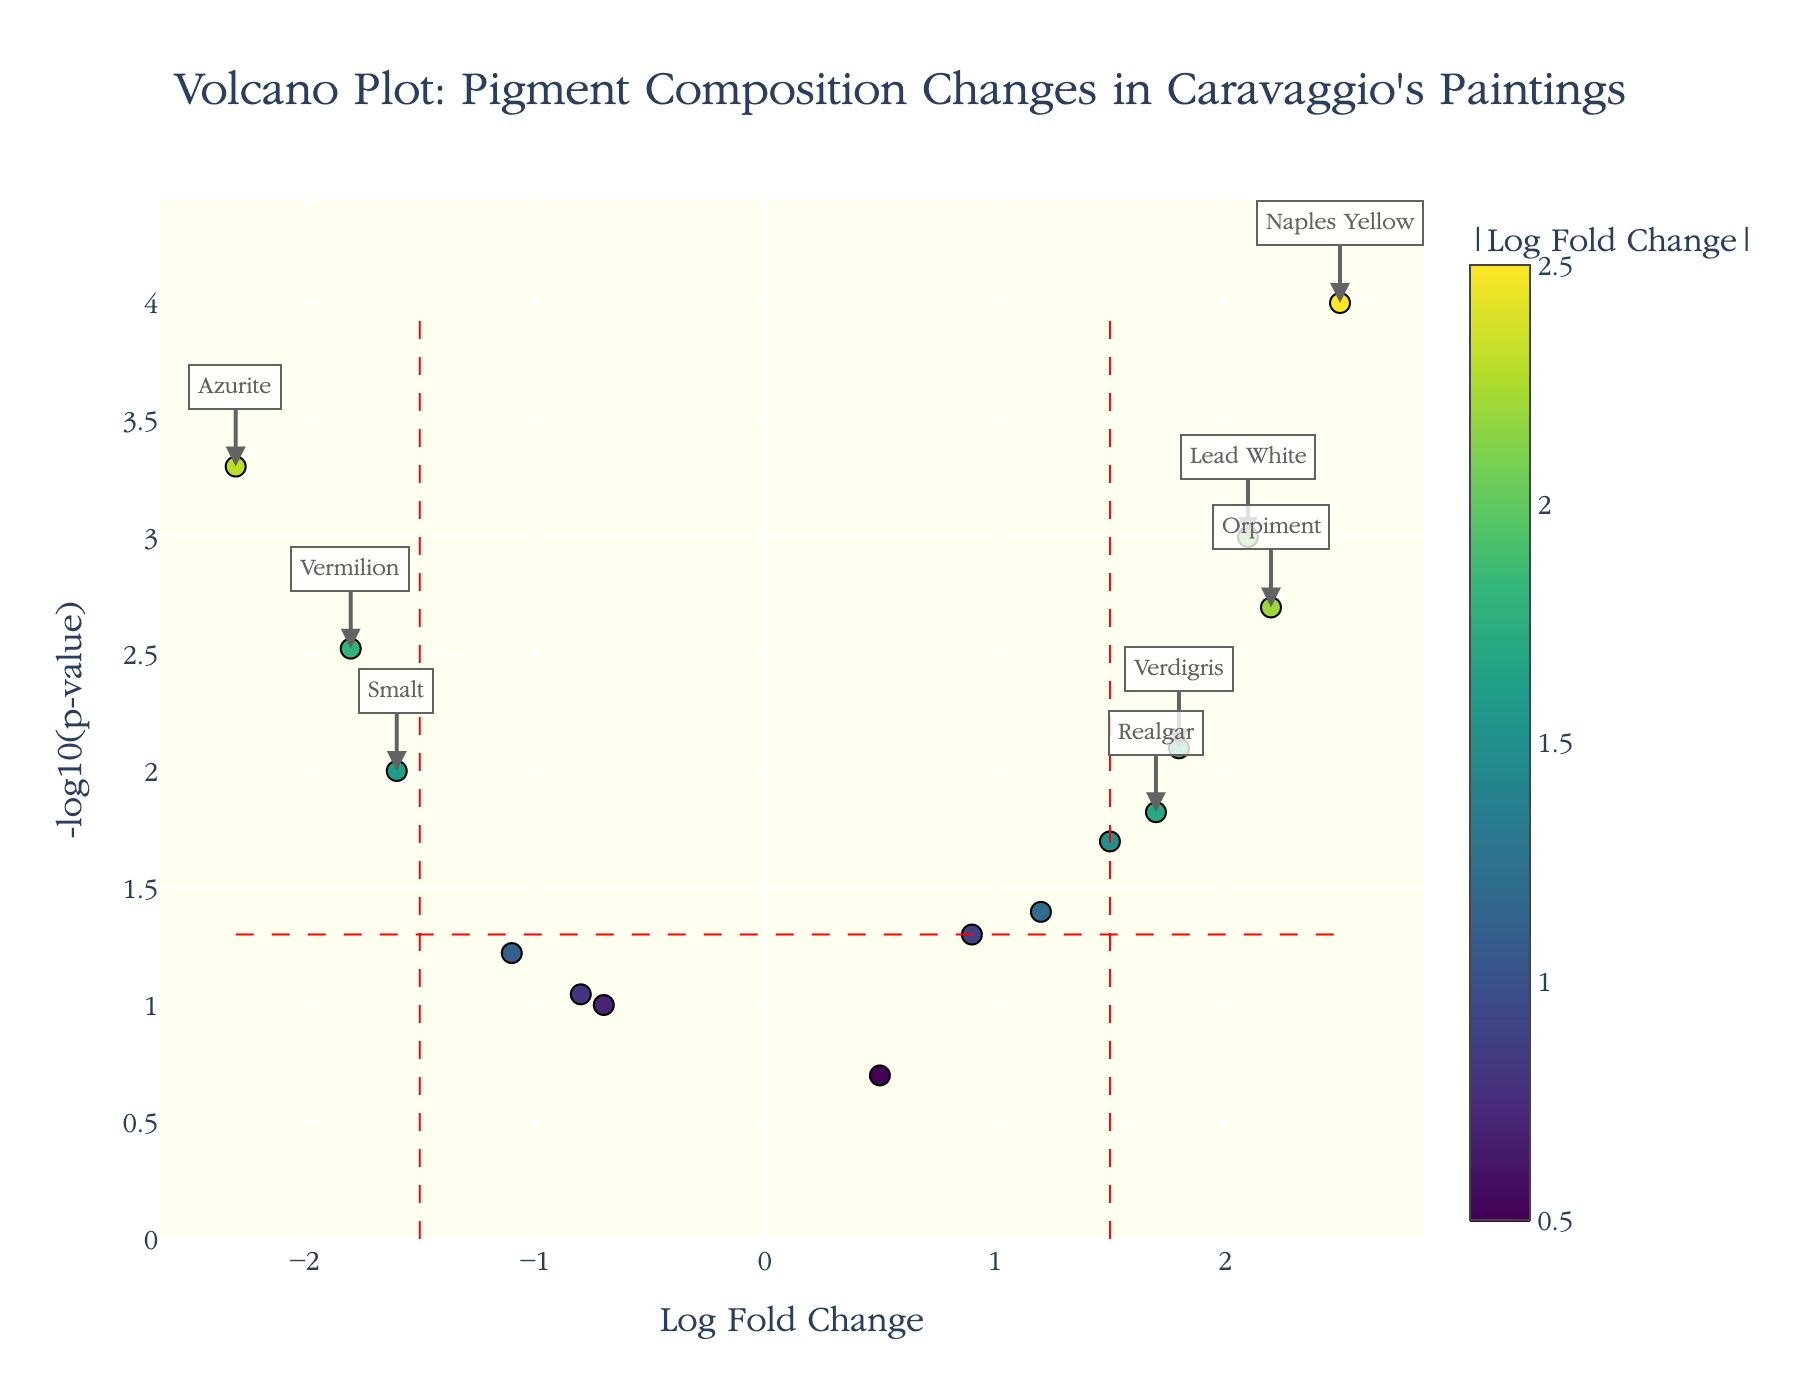What is the title of the plot? The title is usually displayed at the top of the plot and summarizes the main topic of the figure. Here, it states "Volcano Plot: Pigment Composition Changes in Caravaggio's Paintings".
Answer: Volcano Plot: Pigment Composition Changes in Caravaggio's Paintings How are the axes labeled in the plot? The axes labels are provided along the x and y axes. The x-axis is labeled “Log Fold Change,” and the y-axis is labeled “-log10(p-value)”.
Answer: Log Fold Change (x-axis), -log10(p-value) (y-axis) Which pigment shows the highest increase in Log Fold Change? Pigments with the highest positive Log Fold Change are located furthest to the right. “Naples Yellow” is the one with the highest positive Log Fold Change.
Answer: Naples Yellow How many pigments have a p-value lower than 0.05? Pigments with p-values lower than 0.05 are above the horizontal red dashed line (y = -log10(0.05)). Count these data points.
Answer: 9 Which pigment has the most significant decrease in Log Fold Change? Pigments with the most significant negative Log Fold Change are located furthest to the left. “Azurite” shows the most significant decrease.
Answer: Azurite Which pigments are both significant in Log Fold Change and p-value? Examine the pigments that lie outside the red dashed lines for both fold change and p-value. Check those beyond the vertical thresholds (abs(Log Fold Change) > 1.5) and above the horizontal threshold (-log10(p-value) > -log10(0.05)).
Answer: Lead White, Vermilion, Azurite, Verdigris, Naples Yellow, Orpiment, Realgar What is the Log Fold Change and p-value of the pigment Vermilion? The plot's hover text or annotations provide detailed data for individual points. "Vermilion" shows a Log Fold Change of -1.8 and a p-value of 0.003.
Answer: Log Fold Change: -1.8, p-value: 0.003 Compare the Log Fold Changes of Lead White and Orpiment. Which has a higher value? Locate the points for Lead White and Orpiment; compare their x-coordinates. Lead White has a Log Fold Change of 2.1, while Orpiment has 2.2.
Answer: Orpiment Calculate the average Log Fold Change of all pigments. Sum all Log Fold Changes and then divide by the total number of pigments. Calculations: (2.1 - 1.8 + 0.9 + 1.5 - 2.3 + 1.2 - 0.7 + 1.8 + 2.5 - 1.1 + 0.5 - 1.6 + 2.2 - 0.8 + 1.7)/15 = 0.53.
Answer: 0.53 